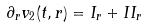<formula> <loc_0><loc_0><loc_500><loc_500>\partial _ { r } v _ { 2 } ( t , r ) = I _ { r } + I I _ { r }</formula> 